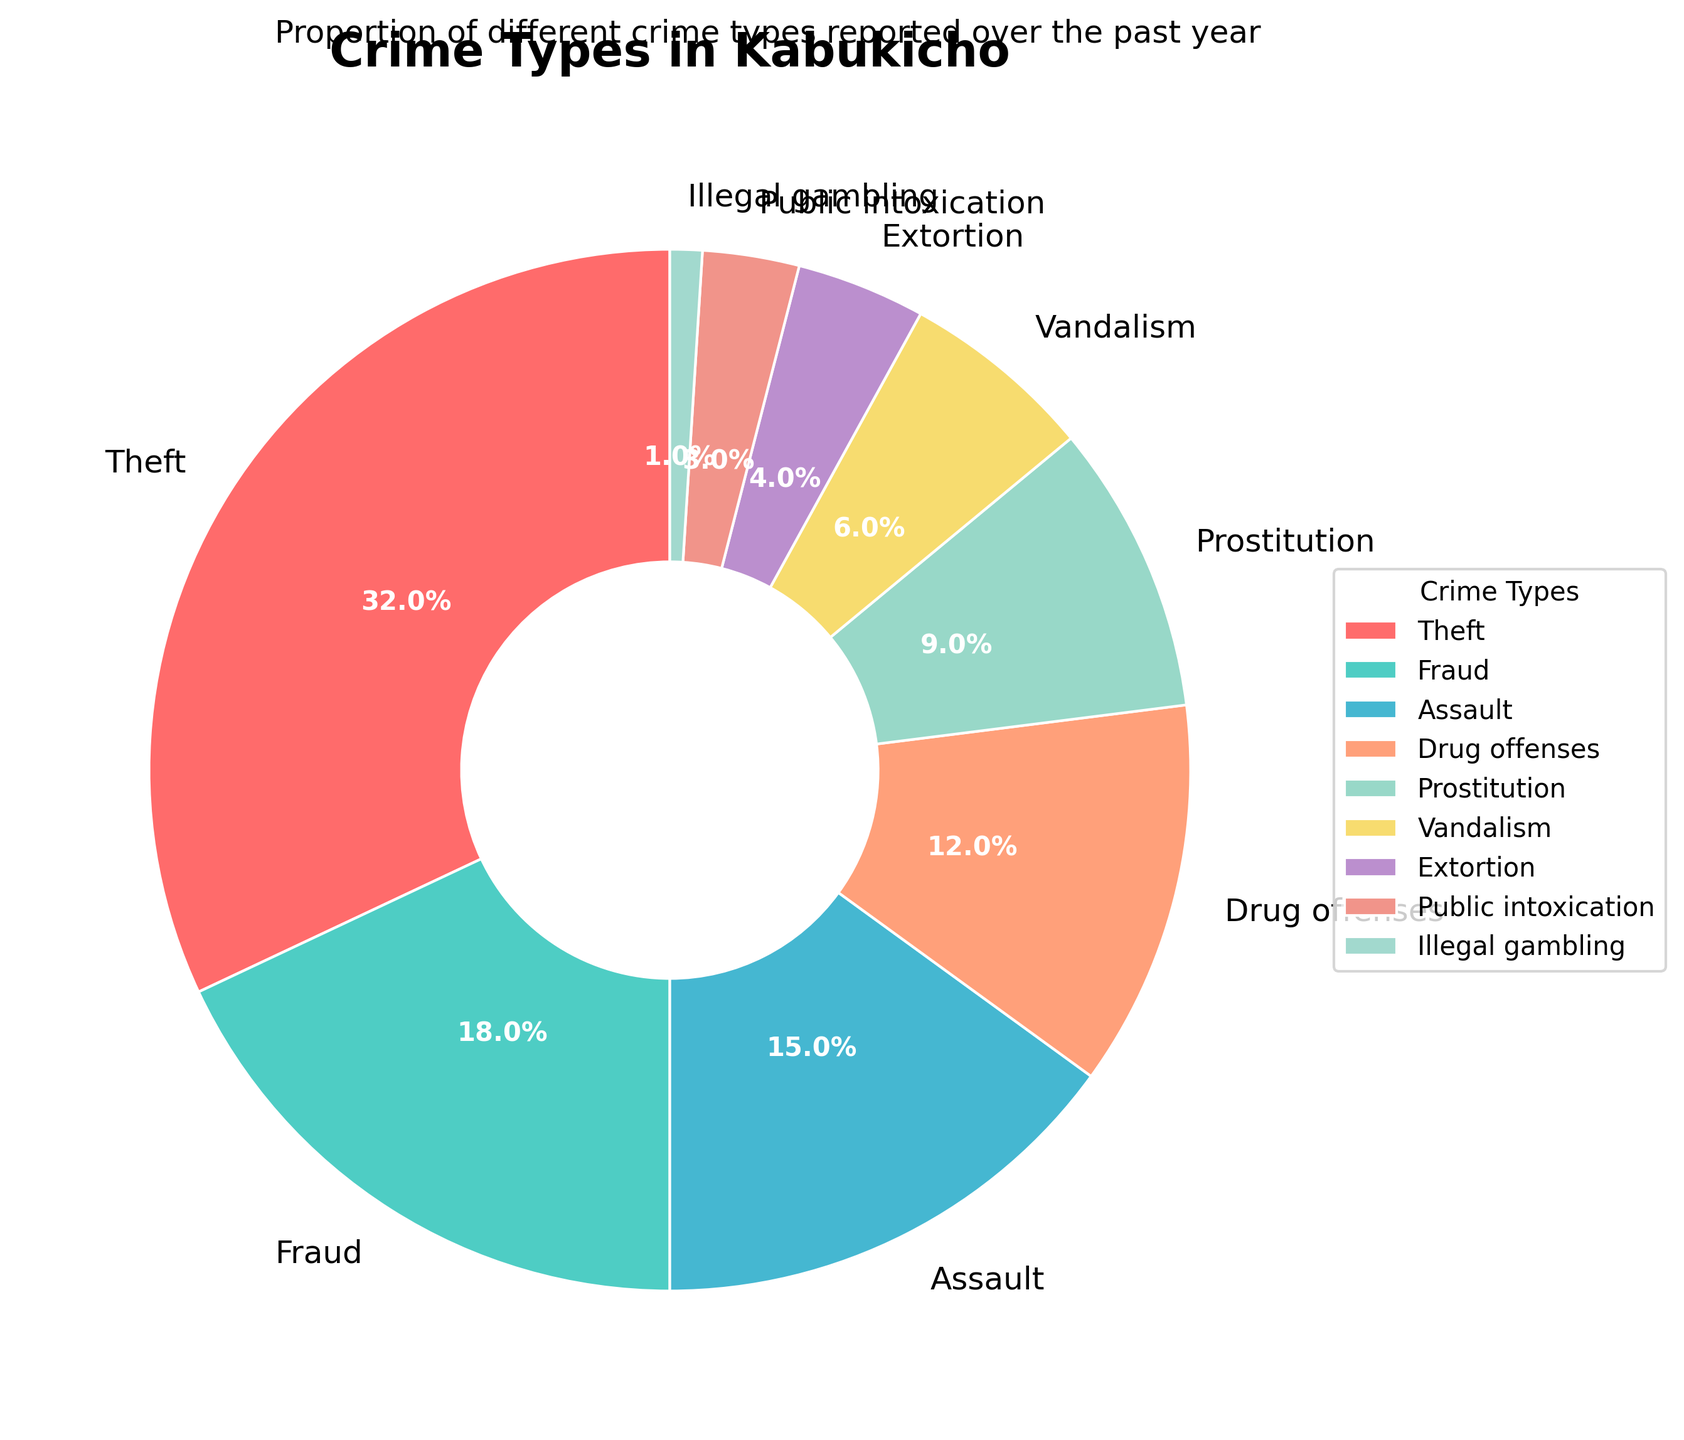Which crime type has the highest percentage? By visually inspecting the size of the pie slices, we see that the 'Theft' slice is the largest.
Answer: Theft What is the combined percentage of Theft and Fraud? Theft has a percentage of 32%, and Fraud has 18%. Adding these together gives 32% + 18% = 50%.
Answer: 50% Are Assault and Drug offenses equally represented? By comparing the size of the pie slices and their labels, we see that Assault is 15% and Drug offenses is 12%. Therefore, they are not equally represented.
Answer: No Which crime type has a smaller percentage, Vandalism or Extortion? By comparing the sizes of the slices labeled Vandalism (6%) and Extortion (4%), we see Extortion is smaller.
Answer: Extortion How does the percentage for Prostitution compare to that for Drug offenses? By examining the chart, Drug offenses have a percentage of 12%, and Prostitution has 9%. Therefore, Drug offenses have a higher percentage than Prostitution.
Answer: Drug offenses are higher What is the percentage difference between Public intoxication and Illegal gambling? Public intoxication is 3% and Illegal gambling is 1%. The difference is calculated as 3% - 1% = 2%.
Answer: 2% How many crime types have a percentage higher than 10%? By looking at the pie chart, the crime types with percentages higher than 10% are Theft (32%), Fraud (18%), Assault (15%), and Drug offenses (12%). There are four such crime types.
Answer: 4 Which crime type is represented by the smallest pie slice? By visually inspecting the pie chart, the smallest slice corresponds to Illegal gambling at 1%.
Answer: Illegal gambling Is the combined percentage of Vandalism, Extortion, and Public intoxication greater than that of Fraud? Vandalism (6%), Extortion (4%), and Public intoxication (3%) combined add up to 6% + 4% + 3% = 13%. Since Fraud is 18%, their combined percentage is not greater than Fraud.
Answer: No What's the average percentage of Prostitution and Vandalism? Prostitution is 9% and Vandalism is 6%. The average is calculated as (9% + 6%) / 2 = 15% / 2 = 7.5%.
Answer: 7.5% 